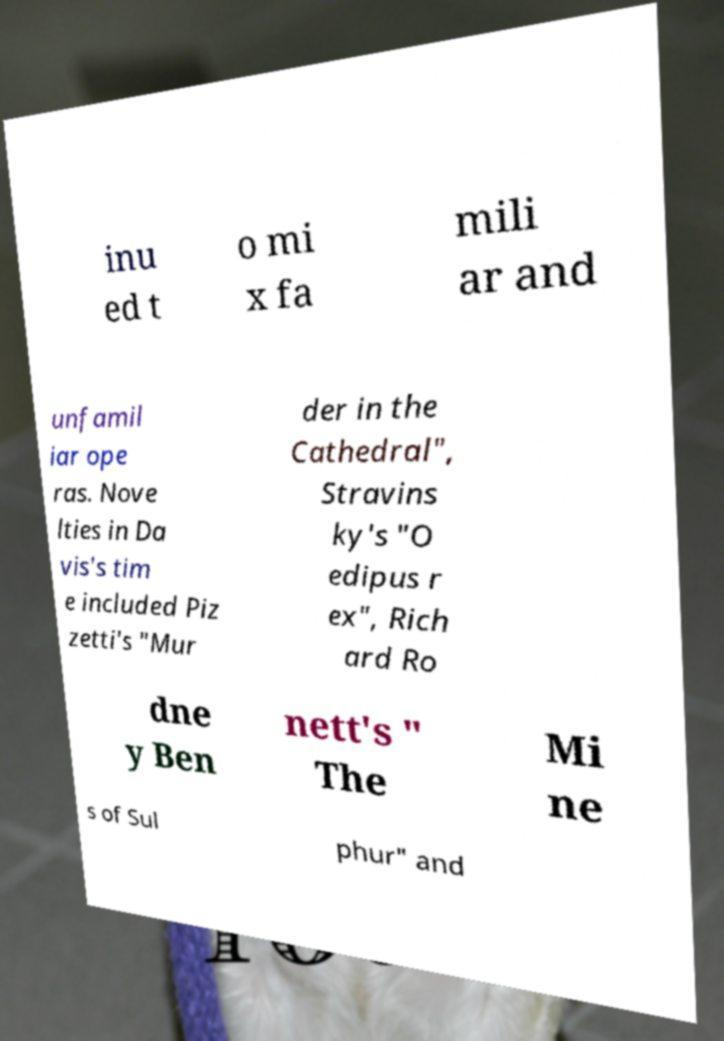Please read and relay the text visible in this image. What does it say? inu ed t o mi x fa mili ar and unfamil iar ope ras. Nove lties in Da vis's tim e included Piz zetti's "Mur der in the Cathedral", Stravins ky's "O edipus r ex", Rich ard Ro dne y Ben nett's " The Mi ne s of Sul phur" and 